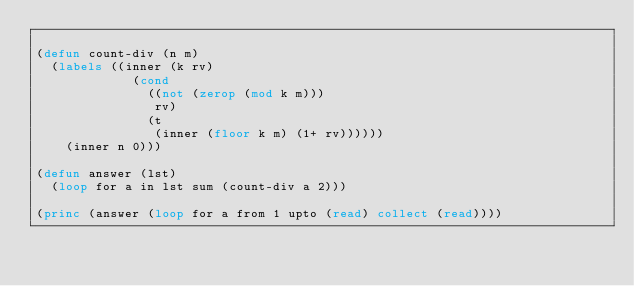<code> <loc_0><loc_0><loc_500><loc_500><_Lisp_>
(defun count-div (n m)
  (labels ((inner (k rv)
             (cond
               ((not (zerop (mod k m)))
                rv)
               (t
                (inner (floor k m) (1+ rv))))))
    (inner n 0)))

(defun answer (lst)
  (loop for a in lst sum (count-div a 2)))

(princ (answer (loop for a from 1 upto (read) collect (read))))
</code> 